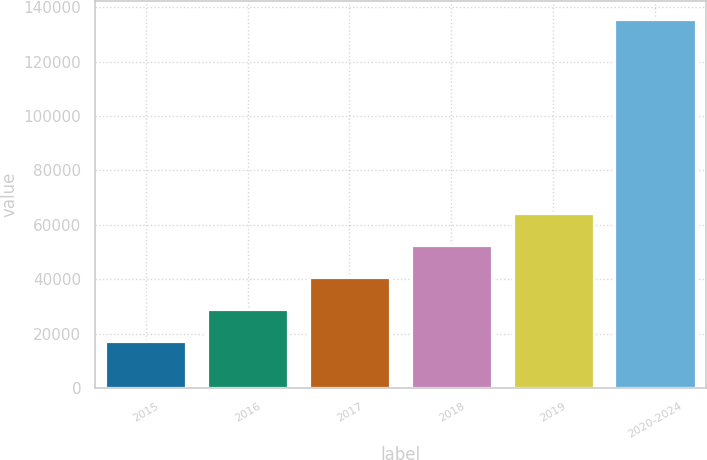Convert chart. <chart><loc_0><loc_0><loc_500><loc_500><bar_chart><fcel>2015<fcel>2016<fcel>2017<fcel>2018<fcel>2019<fcel>2020-2024<nl><fcel>17103<fcel>28959<fcel>40815<fcel>52671<fcel>64527<fcel>135663<nl></chart> 